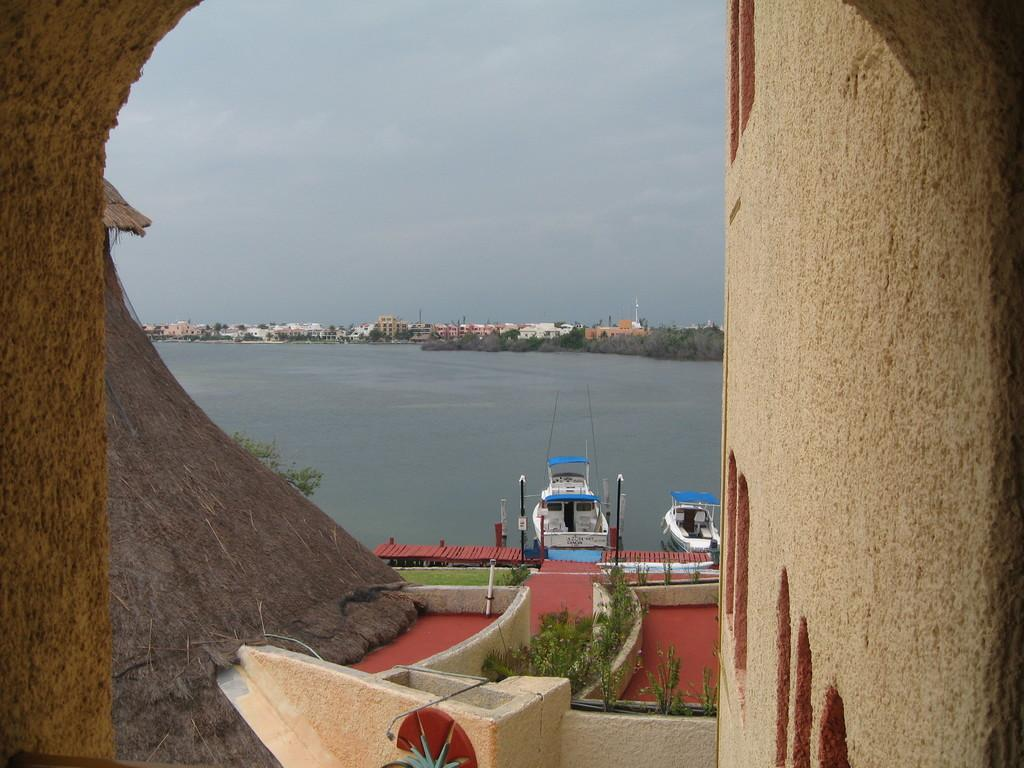What is happening in the water in the image? There are boats sailing on the water in the image. What can be seen in the background of the image? There is a wall, plants, trees, buildings, and poles visible in the image. What is the condition of the sky in the image? The sky is visible in the image. What type of vegetation is present in the image? There are plants and trees visible in the image. What is the ground covered with in the image? There is grass visible in the image. What type of music is being played in the image? There is no indication of music being played in the image. What book is the person reading in the image? There are no people or books visible in the image. 